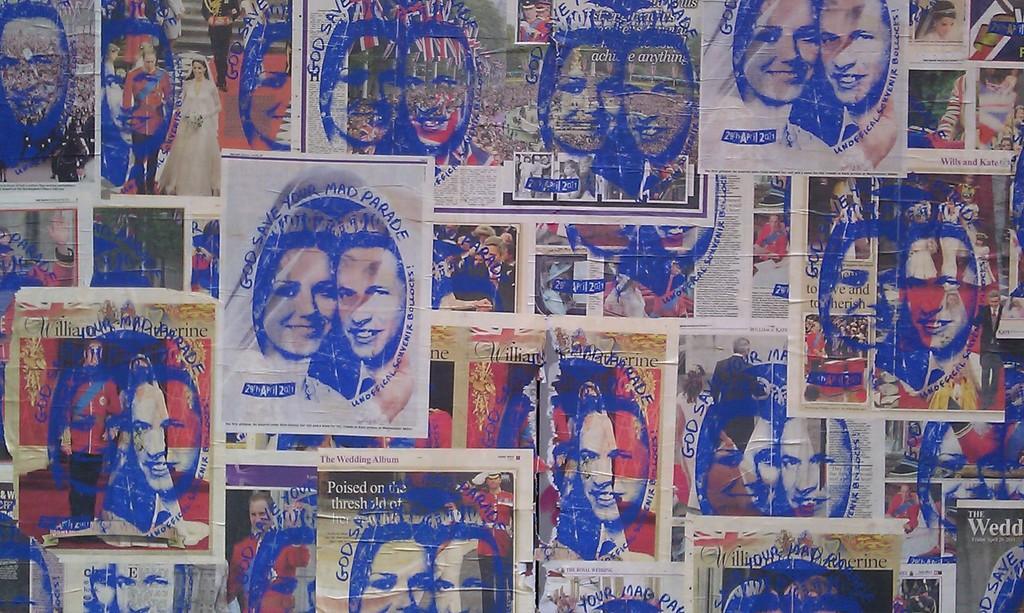How would you summarize this image in a sentence or two? In the center of the image we can see posters. On the posters, we can see a few people and some text. 